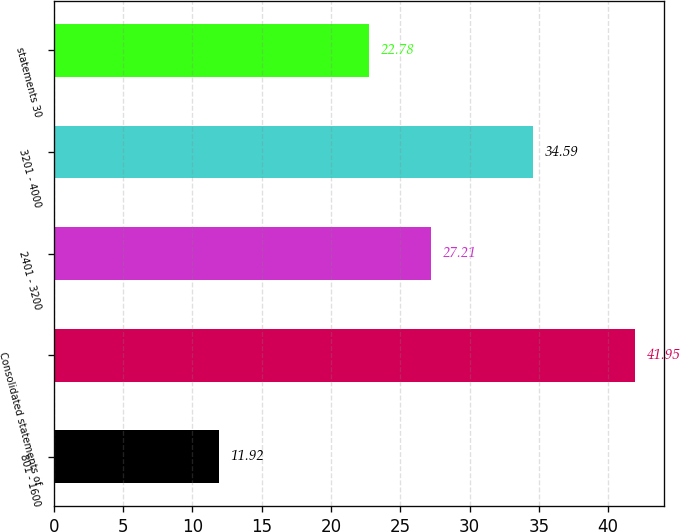Convert chart. <chart><loc_0><loc_0><loc_500><loc_500><bar_chart><fcel>801 - 1600<fcel>Consolidated statements of<fcel>2401 - 3200<fcel>3201 - 4000<fcel>statements 30<nl><fcel>11.92<fcel>41.95<fcel>27.21<fcel>34.59<fcel>22.78<nl></chart> 